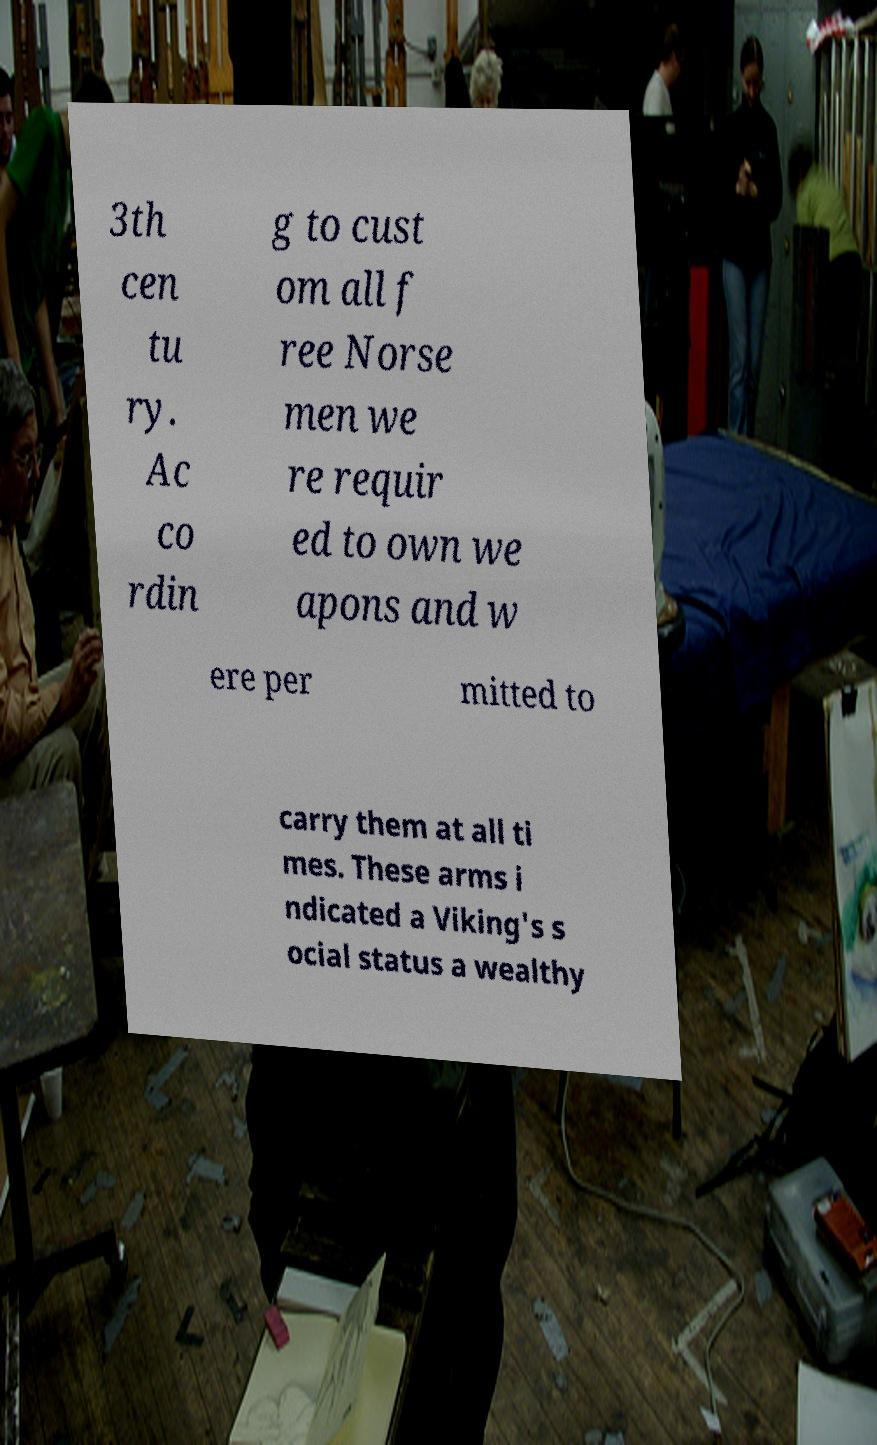Could you extract and type out the text from this image? 3th cen tu ry. Ac co rdin g to cust om all f ree Norse men we re requir ed to own we apons and w ere per mitted to carry them at all ti mes. These arms i ndicated a Viking's s ocial status a wealthy 